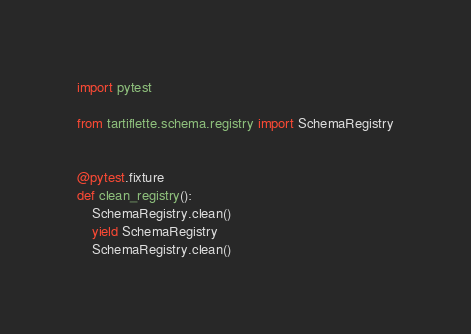Convert code to text. <code><loc_0><loc_0><loc_500><loc_500><_Python_>import pytest

from tartiflette.schema.registry import SchemaRegistry


@pytest.fixture
def clean_registry():
    SchemaRegistry.clean()
    yield SchemaRegistry
    SchemaRegistry.clean()
</code> 